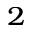Convert formula to latex. <formula><loc_0><loc_0><loc_500><loc_500>^ { 2 }</formula> 